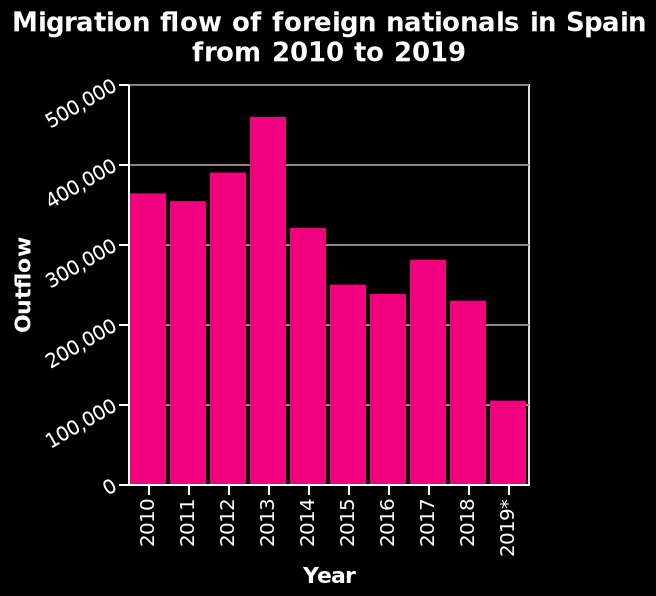<image>
What was the trend of aly liie from 2014 to 2019?  From 2014 to 2019, aly liie showed a downward trend to just above 100,000. What was the peak of aly liie in 2013?  The peak of aly liie in 2013 was 450,000. What is the title or name of the bar graph?  The bar graph is called Migration flow of foreign nationals in Spain from 2010 to 2019. 